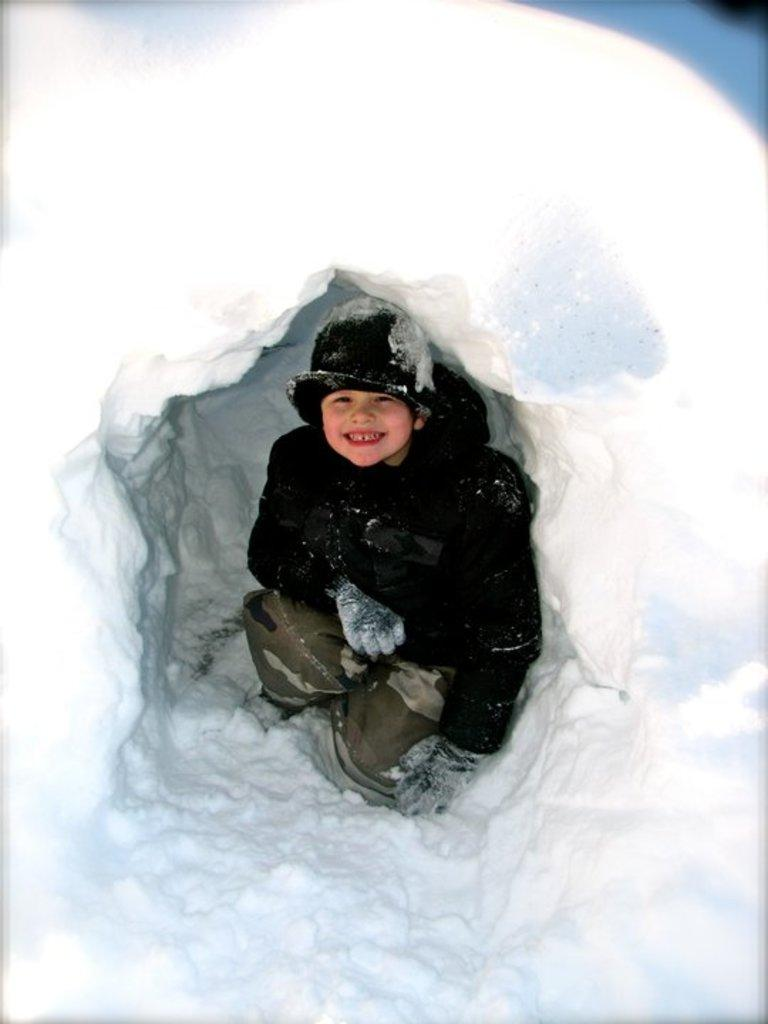Who is present in the image? There is a boy in the image. Where is the boy located in the image? The boy is visible under a snow tent. What type of hose is the boy using for the activity in the image? There is no hose present in the image, and no activity is mentioned or visible. 